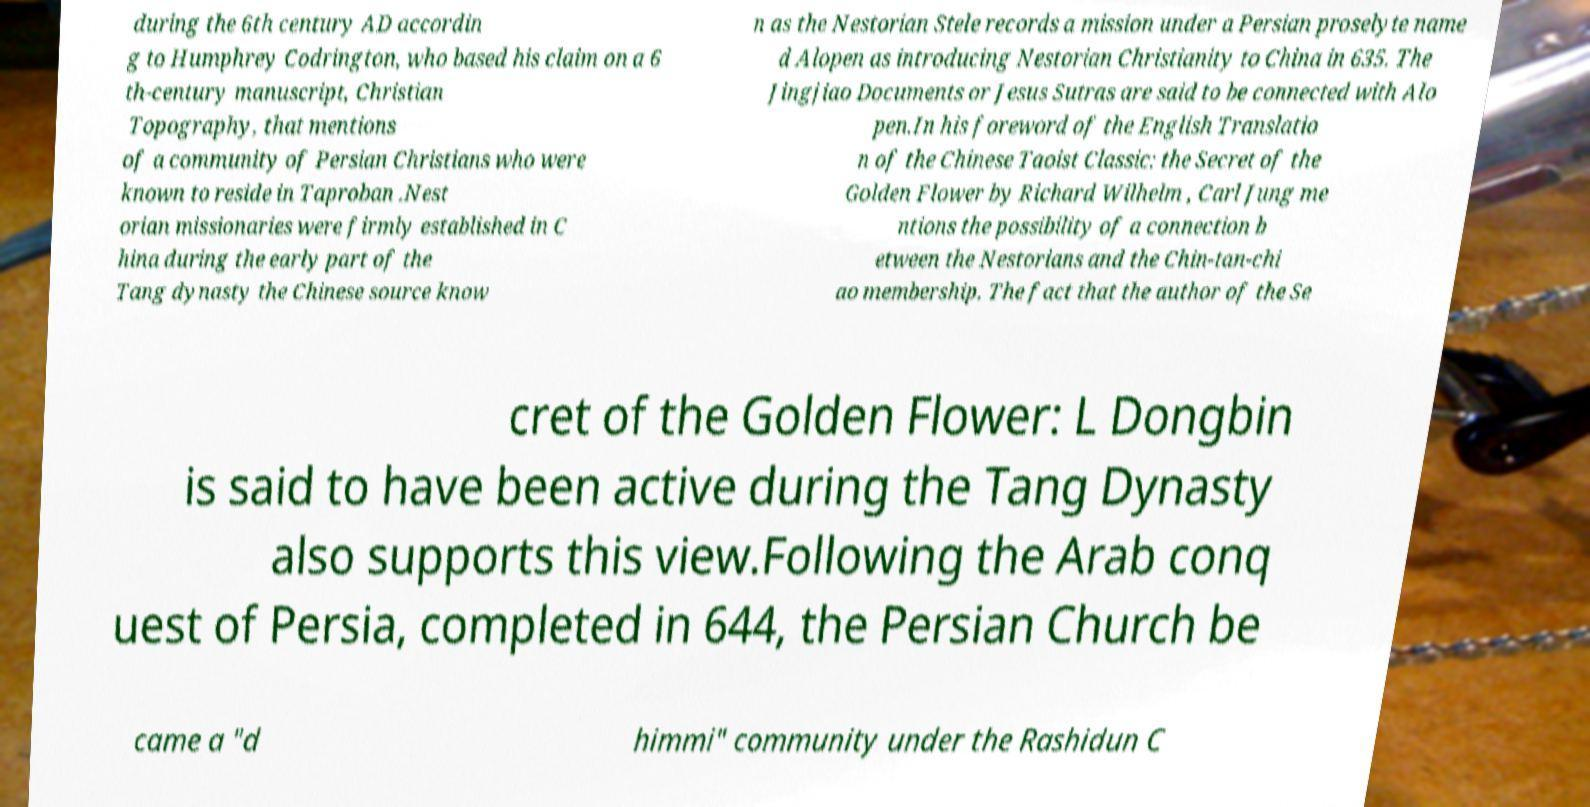There's text embedded in this image that I need extracted. Can you transcribe it verbatim? during the 6th century AD accordin g to Humphrey Codrington, who based his claim on a 6 th-century manuscript, Christian Topography, that mentions of a community of Persian Christians who were known to reside in Taproban .Nest orian missionaries were firmly established in C hina during the early part of the Tang dynasty the Chinese source know n as the Nestorian Stele records a mission under a Persian proselyte name d Alopen as introducing Nestorian Christianity to China in 635. The Jingjiao Documents or Jesus Sutras are said to be connected with Alo pen.In his foreword of the English Translatio n of the Chinese Taoist Classic: the Secret of the Golden Flower by Richard Wilhelm , Carl Jung me ntions the possibility of a connection b etween the Nestorians and the Chin-tan-chi ao membership. The fact that the author of the Se cret of the Golden Flower: L Dongbin is said to have been active during the Tang Dynasty also supports this view.Following the Arab conq uest of Persia, completed in 644, the Persian Church be came a "d himmi" community under the Rashidun C 